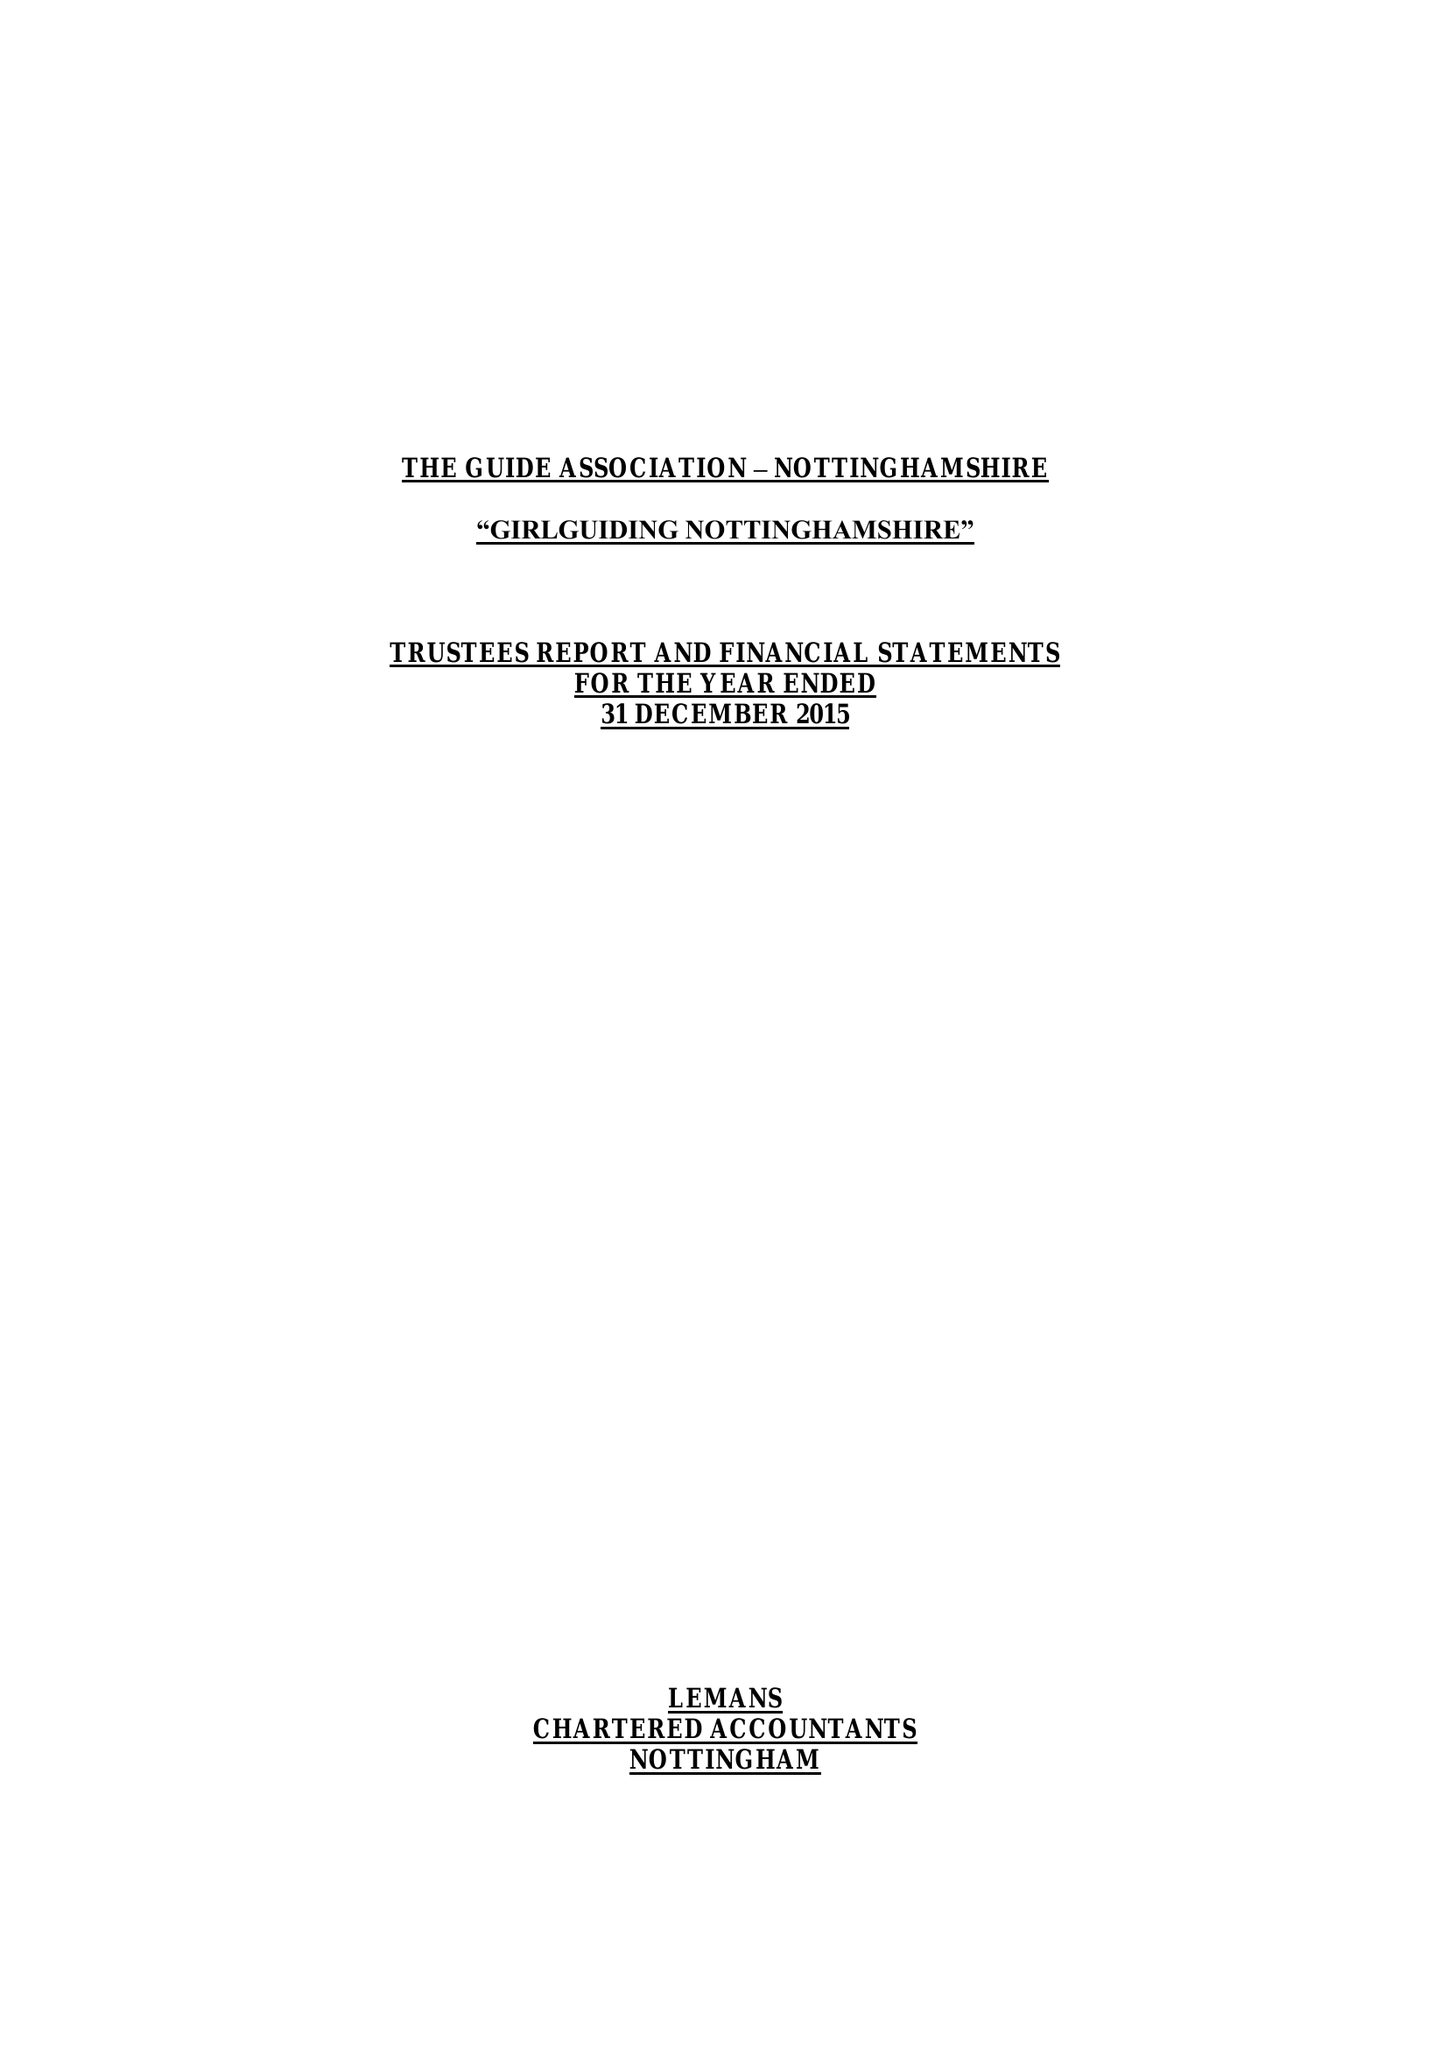What is the value for the address__post_town?
Answer the question using a single word or phrase. NOTTINGHAM 